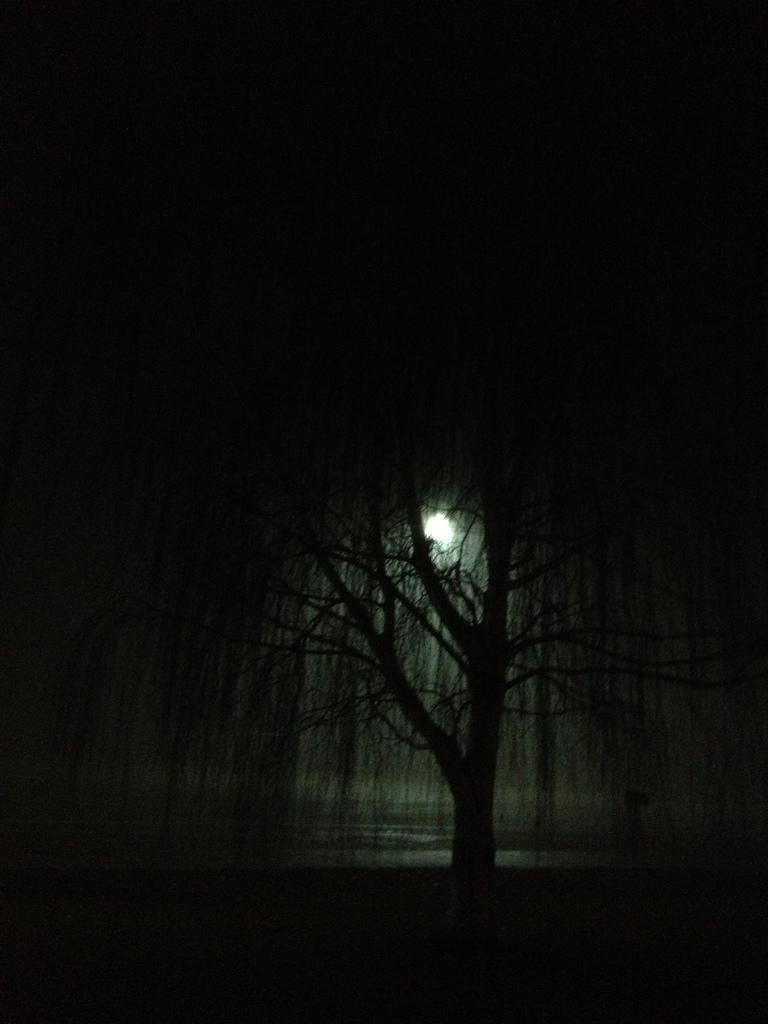What is the main object in the image? There is a tree in the image. How would you describe the background of the image? The background of the image is dark. Can you see a house with a horn in the image? There is no house or horn present in the image; it only features a tree with a dark background. 